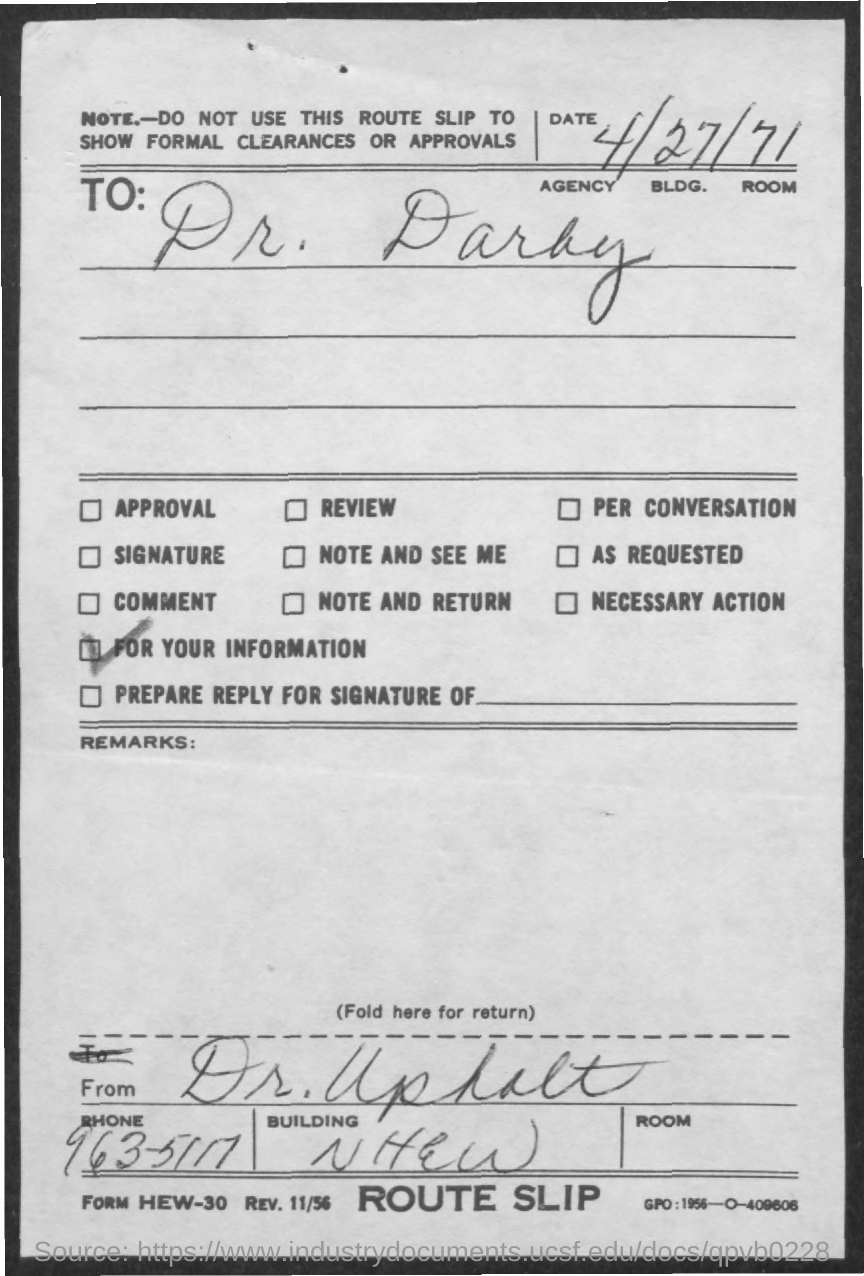What is the phone no. mentioned in the given slip ?
Your answer should be very brief. 963-5117. To whom the route slip was given ?
Offer a terse response. Dr. Darby. 